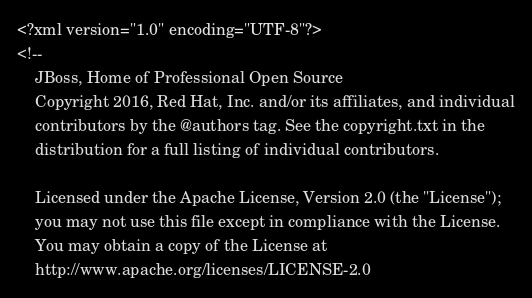Convert code to text. <code><loc_0><loc_0><loc_500><loc_500><_XML_><?xml version="1.0" encoding="UTF-8"?>
<!--
    JBoss, Home of Professional Open Source
    Copyright 2016, Red Hat, Inc. and/or its affiliates, and individual
    contributors by the @authors tag. See the copyright.txt in the
    distribution for a full listing of individual contributors.

    Licensed under the Apache License, Version 2.0 (the "License");
    you may not use this file except in compliance with the License.
    You may obtain a copy of the License at
    http://www.apache.org/licenses/LICENSE-2.0</code> 